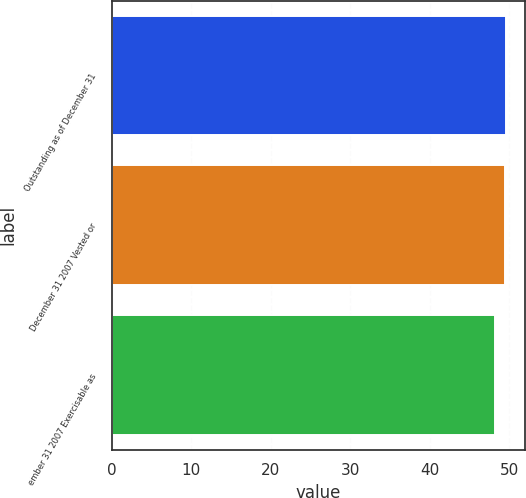Convert chart to OTSL. <chart><loc_0><loc_0><loc_500><loc_500><bar_chart><fcel>Outstanding as of December 31<fcel>December 31 2007 Vested or<fcel>ember 31 2007 Exercisable as<nl><fcel>49.52<fcel>49.39<fcel>48.15<nl></chart> 